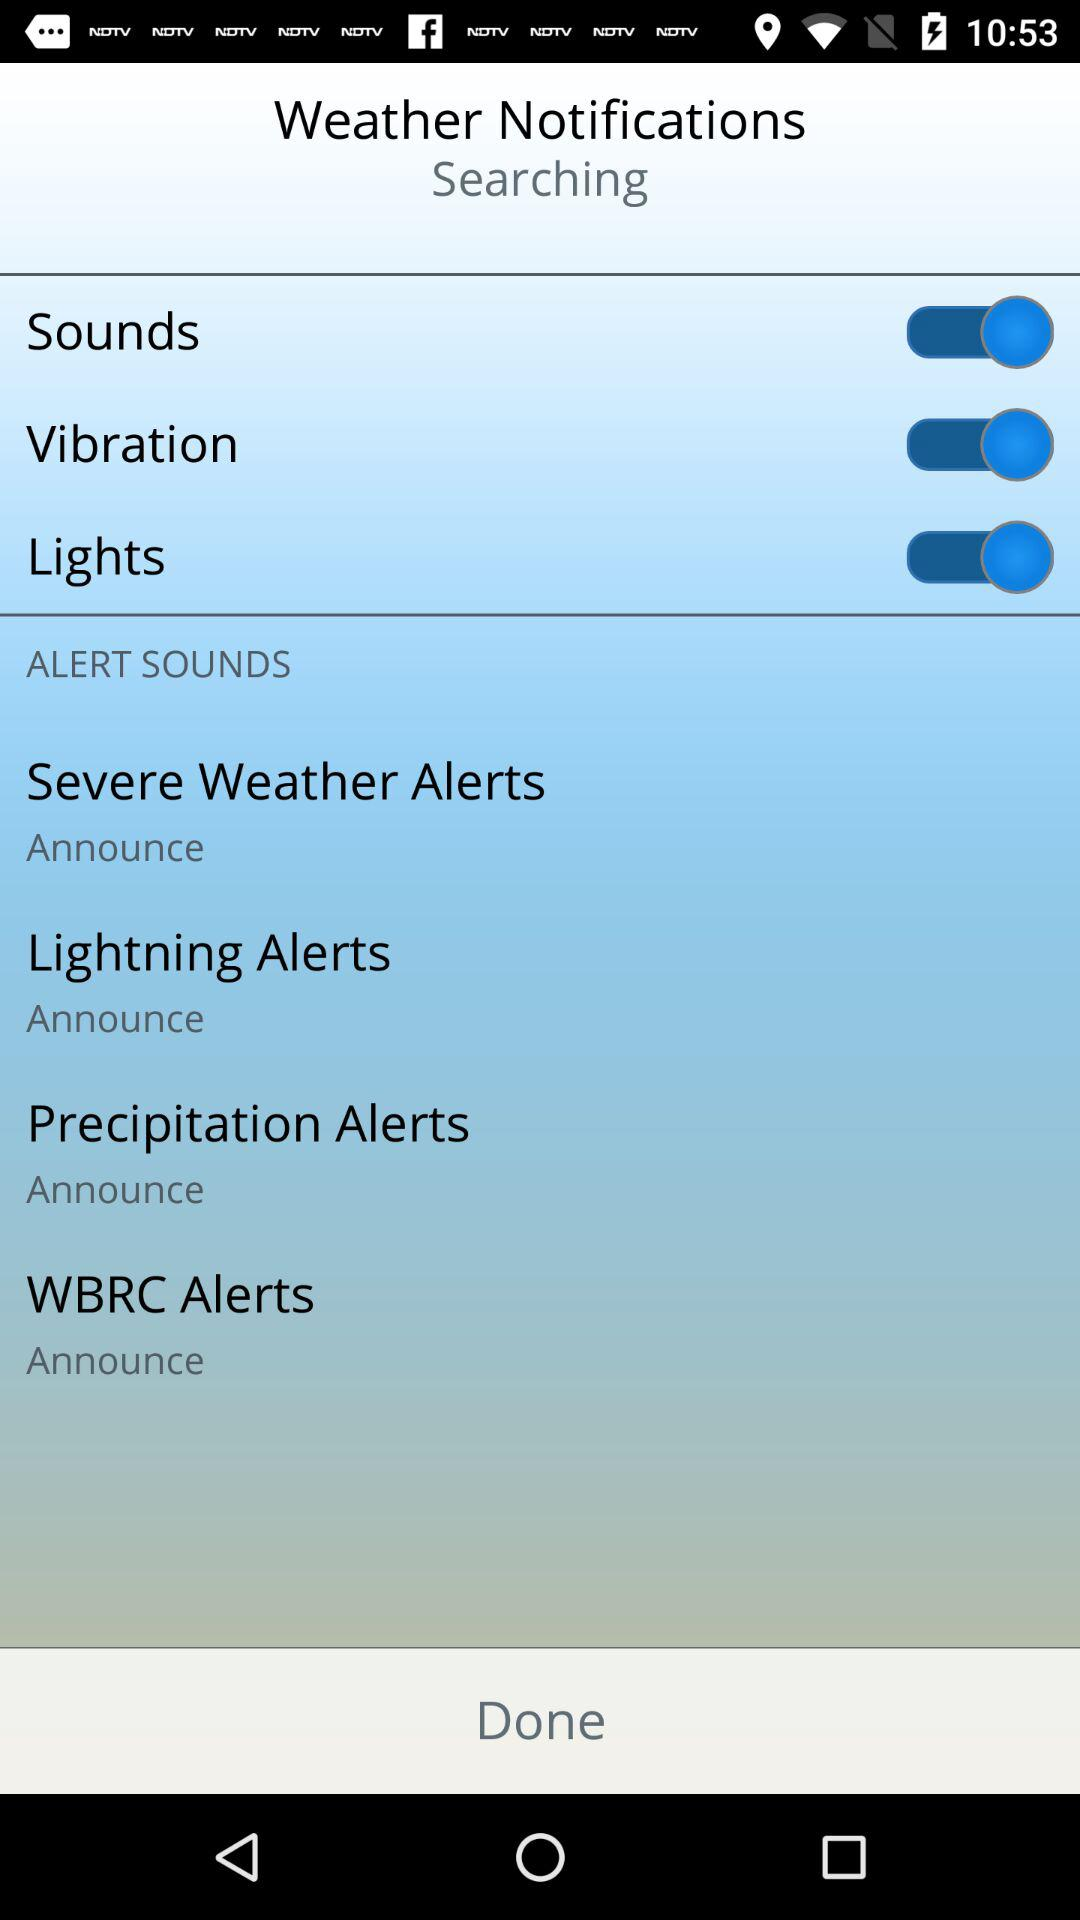What is the status of vibration? The status is on. 